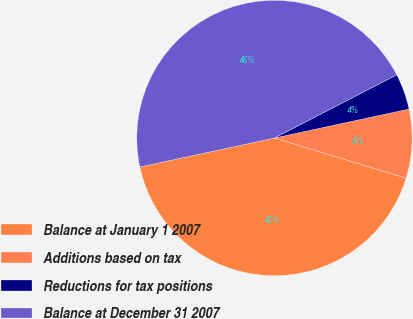<chart> <loc_0><loc_0><loc_500><loc_500><pie_chart><fcel>Balance at January 1 2007<fcel>Additions based on tax<fcel>Reductions for tax positions<fcel>Balance at December 31 2007<nl><fcel>41.92%<fcel>8.08%<fcel>4.22%<fcel>45.78%<nl></chart> 